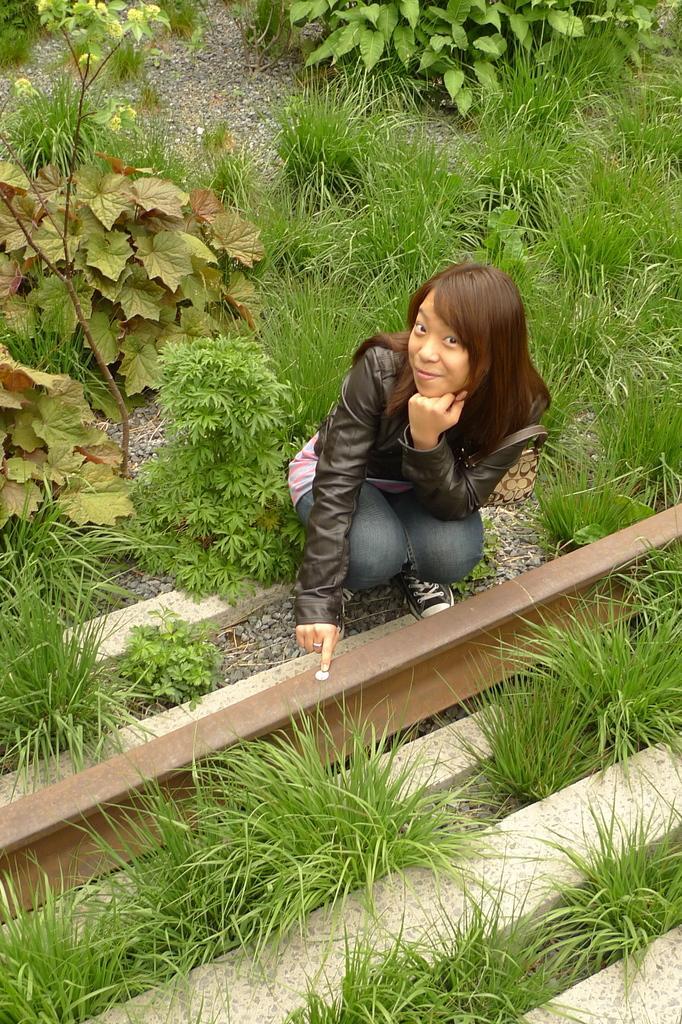Describe this image in one or two sentences. In this image a lady is in a crouched position. On the ground there are grasses, plants. 